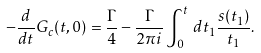<formula> <loc_0><loc_0><loc_500><loc_500>- \frac { d } { d t } G _ { c } ( t , 0 ) = \frac { \Gamma } { 4 } - \frac { \Gamma } { 2 \pi i } \int ^ { t } _ { 0 } \, d t _ { 1 } \frac { s ( t _ { 1 } ) } { t _ { 1 } } .</formula> 